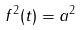<formula> <loc_0><loc_0><loc_500><loc_500>f ^ { 2 } ( t ) = a ^ { 2 }</formula> 